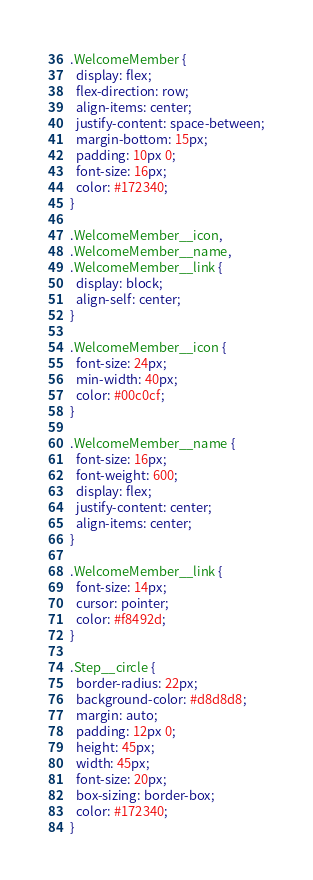Convert code to text. <code><loc_0><loc_0><loc_500><loc_500><_CSS_>.WelcomeMember {
  display: flex;
  flex-direction: row;
  align-items: center;
  justify-content: space-between;
  margin-bottom: 15px;
  padding: 10px 0;
  font-size: 16px;
  color: #172340;
}

.WelcomeMember__icon,
.WelcomeMember__name,
.WelcomeMember__link {
  display: block;
  align-self: center;
}

.WelcomeMember__icon {
  font-size: 24px;
  min-width: 40px;
  color: #00c0cf;
}

.WelcomeMember__name {
  font-size: 16px;
  font-weight: 600;
  display: flex;
  justify-content: center;
  align-items: center;
}

.WelcomeMember__link {
  font-size: 14px;
  cursor: pointer;
  color: #f8492d;
}

.Step__circle {
  border-radius: 22px;
  background-color: #d8d8d8;
  margin: auto;
  padding: 12px 0;
  height: 45px;
  width: 45px;
  font-size: 20px;
  box-sizing: border-box;
  color: #172340;
}
</code> 